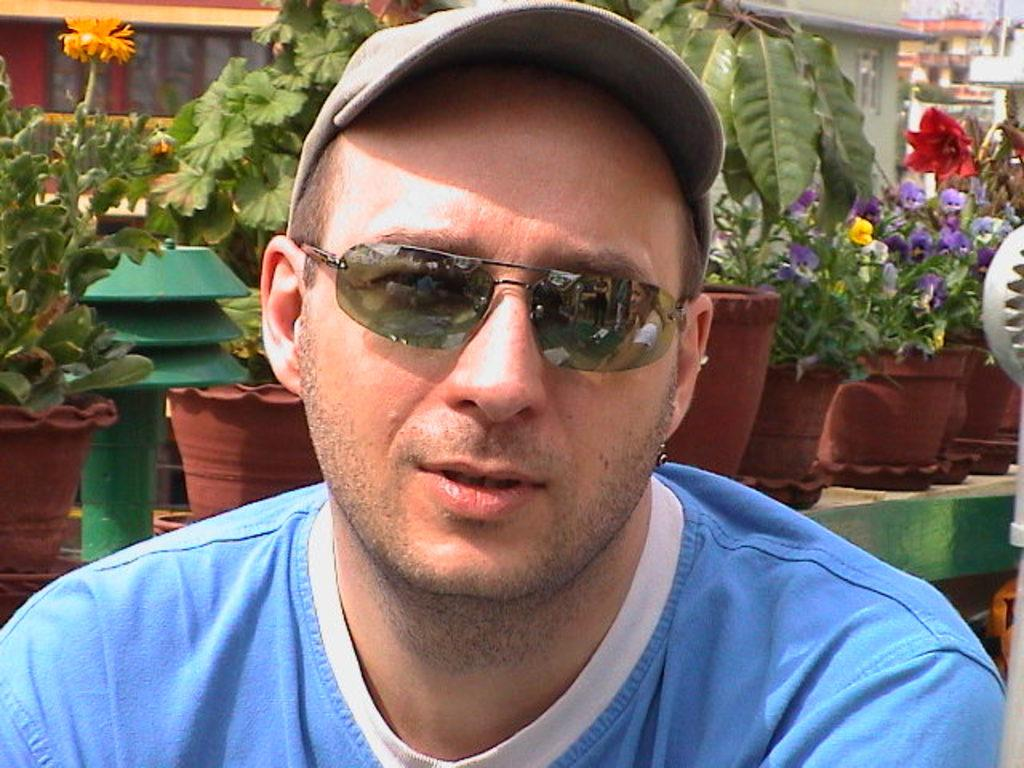What is the main subject of the image? There is a person in the image. What protective gear is the person wearing? The person is wearing goggles. What type of headwear is the person wearing? The person is wearing a cap. What can be seen in the background of the image? There are pots with flowering plants and many buildings in the background. How many feet of corn can be seen in the image? There is no corn present in the image, so it is not possible to determine the number of feet of corn. 